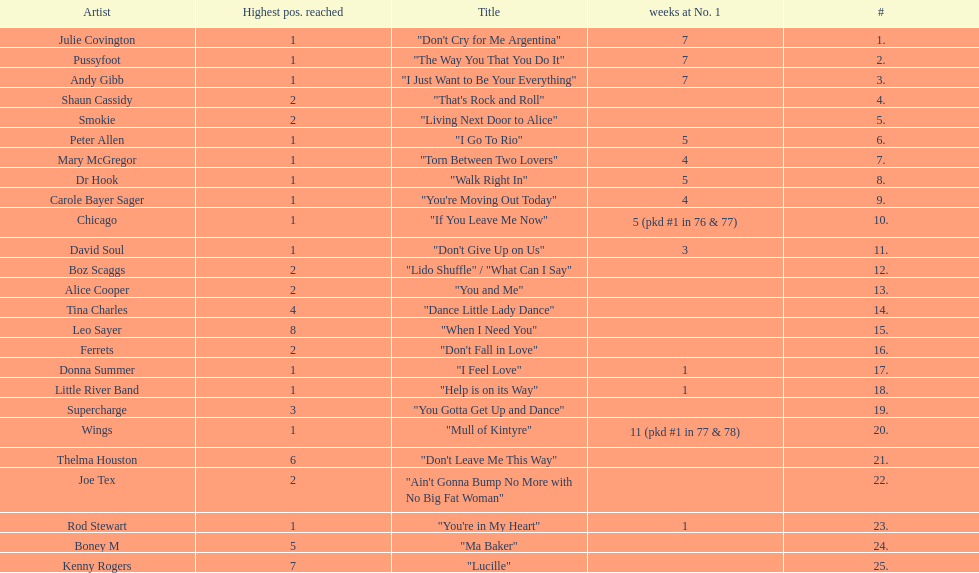Which three artists had a single at number 1 for at least 7 weeks on the australian singles charts in 1977? Julie Covington, Pussyfoot, Andy Gibb. 